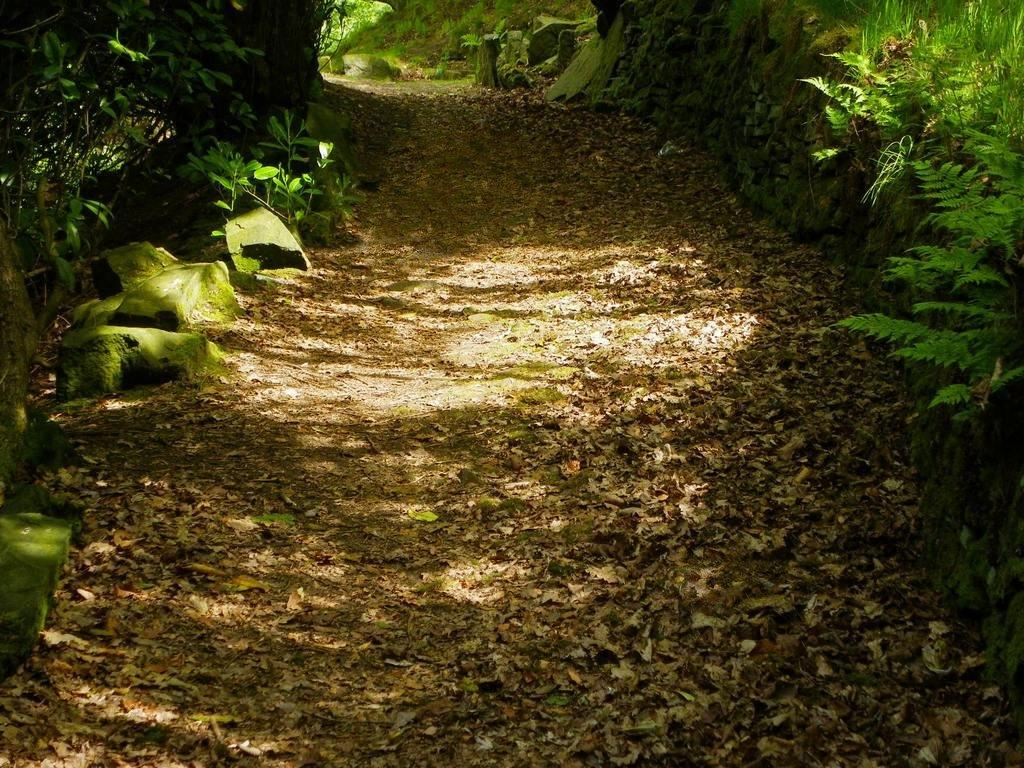What can be seen running through the image? There is a path in the image. What is covering the path in the image? Dried leaves are present on the path. What is located on either side of the path? There are rocks and plants on either side of the path. What is growing on the rocks in the image? Algae is visible on the rocks. Where is the quince tree located in the image? There is no quince tree present in the image. What type of playground equipment can be seen in the image? There is no playground equipment present in the image. 